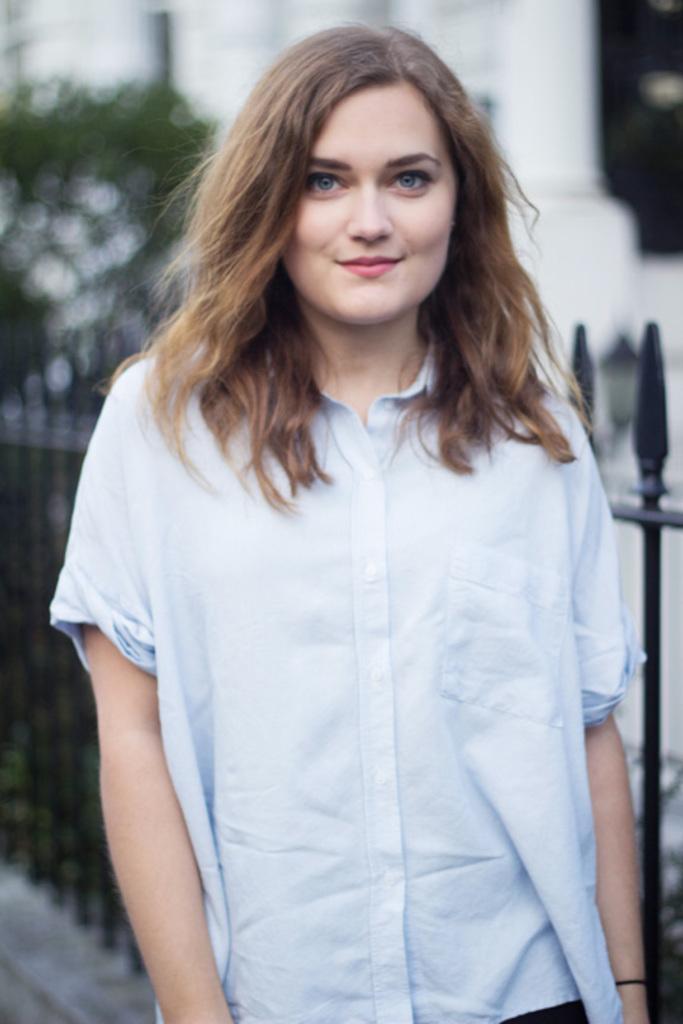Could you give a brief overview of what you see in this image? In this image there is a girl who is wearing the white color shirt. Behind her there is fence. In the background there is building. On the left side there is a tree. 